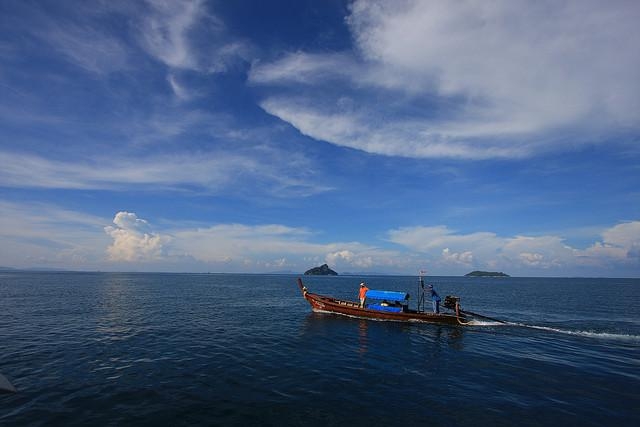What propels this craft forward? Please explain your reasoning. motor. There is a wake behind the boat and its front is out of the water, suggesting something is causing it to move rapidly. 